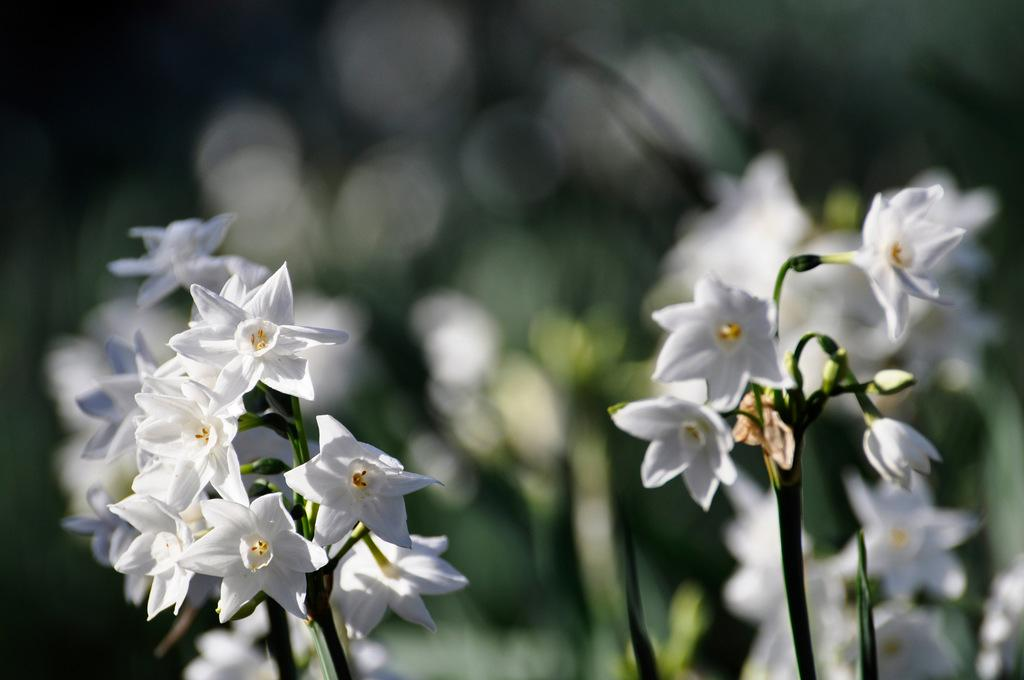What type of plants can be seen in the image? There are plants with flowers in the image. Can you describe the background of the image? The background of the image is blurred. Is there a brush visible in the image? No, there is no brush present in the image. Can you see a bike in the image? No, there is no bike present in the image. 